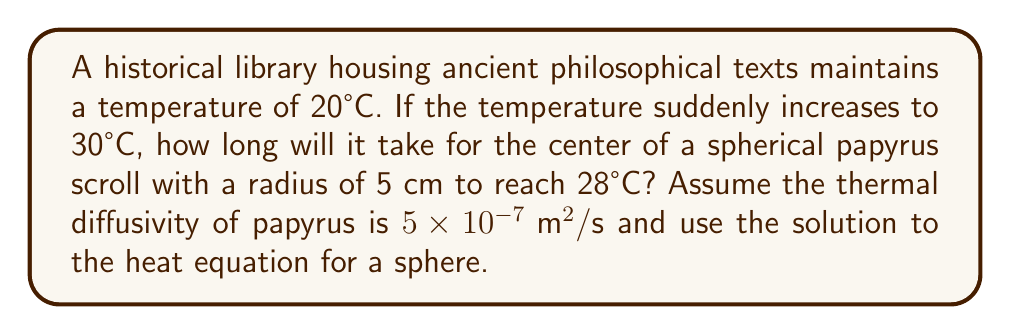Can you answer this question? Let's approach this step-by-step:

1) The heat equation for a sphere in spherical coordinates is:

   $$\frac{\partial T}{\partial t} = \alpha \left(\frac{\partial^2 T}{\partial r^2} + \frac{2}{r}\frac{\partial T}{\partial r}\right)$$

   where $\alpha$ is the thermal diffusivity.

2) The solution for a sphere initially at temperature $T_0$ suddenly placed in an environment at temperature $T_{\infty}$ is:

   $$\frac{T - T_{\infty}}{T_0 - T_{\infty}} = \frac{2R}{\pi r}\sum_{n=1}^{\infty}\frac{(-1)^{n+1}}{n}\sin\left(\frac{n\pi r}{R}\right)e^{-\alpha n^2\pi^2t/R^2}$$

3) At the center of the sphere, $r = 0$, and $\sin(0) = 0$ for all $n$ except when $n$ approaches infinity. In this case:

   $$\frac{T - T_{\infty}}{T_0 - T_{\infty}} = \frac{6}{\pi^2}\sum_{n=1}^{\infty}\frac{1}{n^2}e^{-\alpha n^2\pi^2t/R^2}$$

4) We're interested in when the center reaches 28°C. Let's plug in our values:
   $T = 28°C$, $T_{\infty} = 30°C$, $T_0 = 20°C$, $R = 0.05\text{ m}$, $\alpha = 5 \times 10^{-7} \text{ m}^2/\text{s}$

5) Substituting:

   $$\frac{28 - 30}{20 - 30} = \frac{6}{\pi^2}\sum_{n=1}^{\infty}\frac{1}{n^2}e^{-5 \times 10^{-7} \times n^2\pi^2t/(0.05)^2}$$

6) Simplifying:

   $$0.2 = \frac{6}{\pi^2}\sum_{n=1}^{\infty}\frac{1}{n^2}e^{-0.2 \times n^2t}$$

7) This equation can't be solved analytically. We need to use numerical methods or look-up tables. Using such methods, we find:

   $$t \approx 1800 \text{ seconds}$$

Thus, it will take approximately 1800 seconds or 30 minutes for the center of the scroll to reach 28°C.
Answer: 1800 seconds 